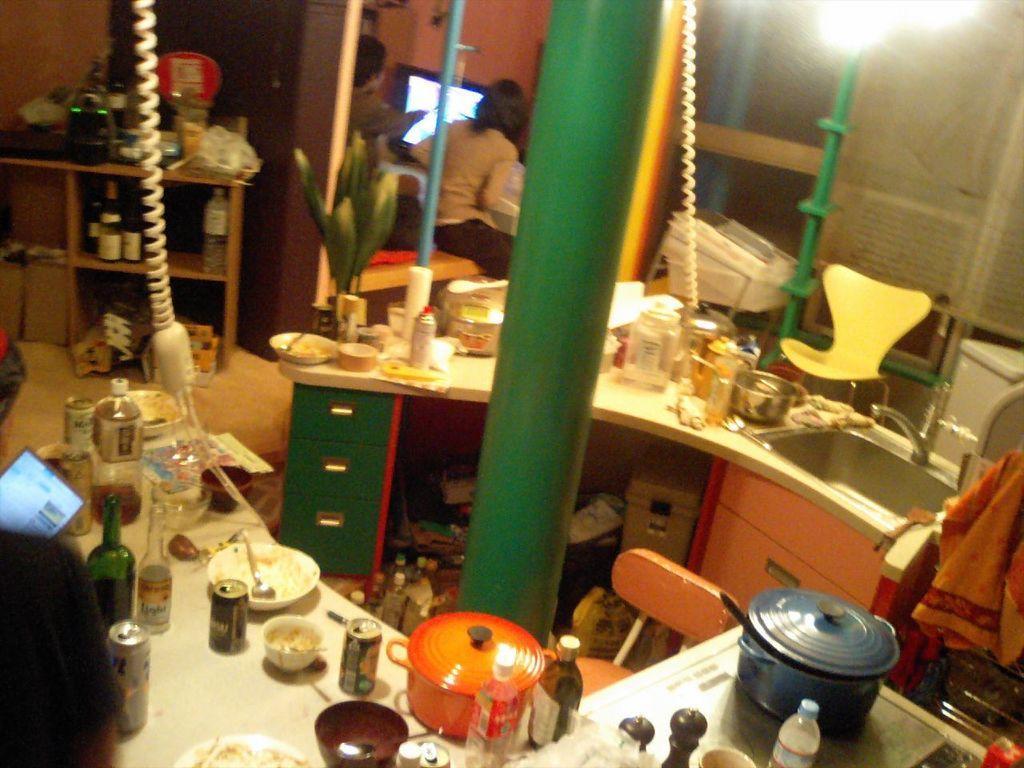Please provide a concise description of this image. This image looks like it is clicked in a kitchen. In this image, we can see many utensils and bottles along with the tins. In the front, there is a pillar along with the cupboards. In the middle, there is a chair. On the right, it looks like a stove. Beside which there is a sink. In the background, there are two persons sitting in front of the TV. On the left, there is a rack and a telephone hanging. 